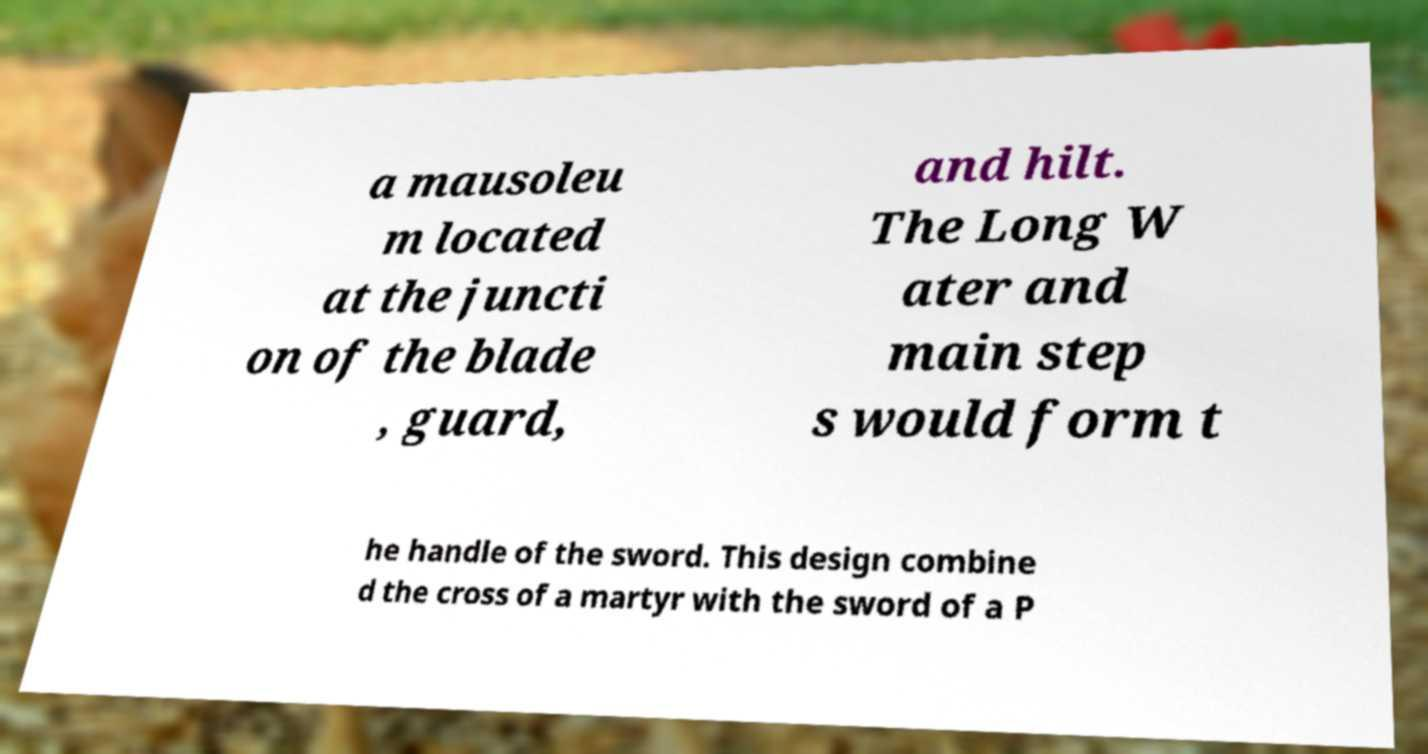Please identify and transcribe the text found in this image. a mausoleu m located at the juncti on of the blade , guard, and hilt. The Long W ater and main step s would form t he handle of the sword. This design combine d the cross of a martyr with the sword of a P 